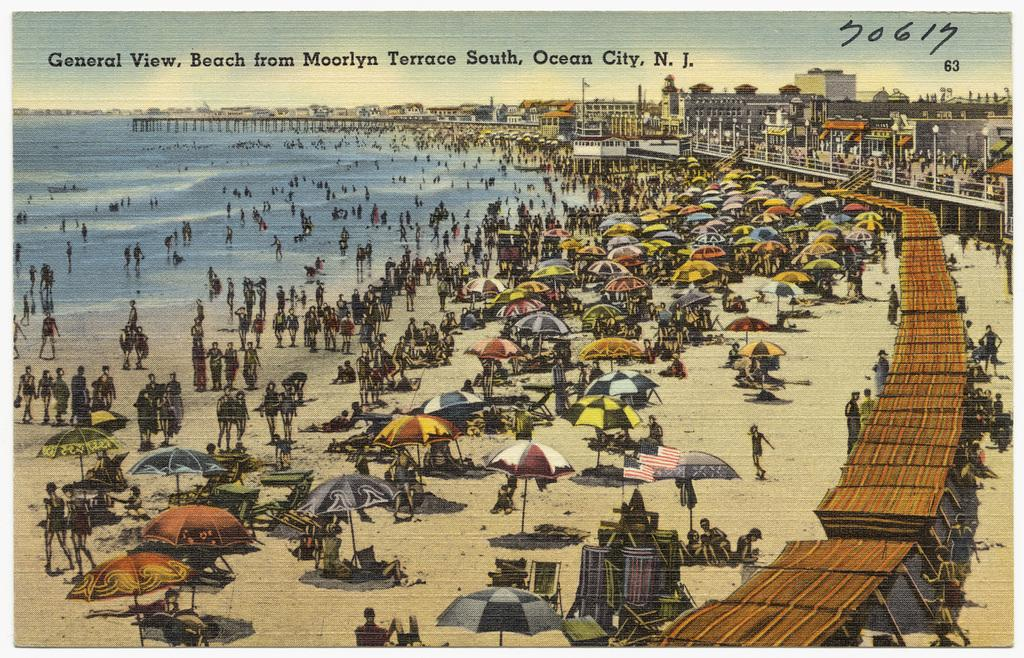<image>
Write a terse but informative summary of the picture. A cartoon drawing of a beach from Moorlyn Terrace South, Ocean City, New Jersey. 